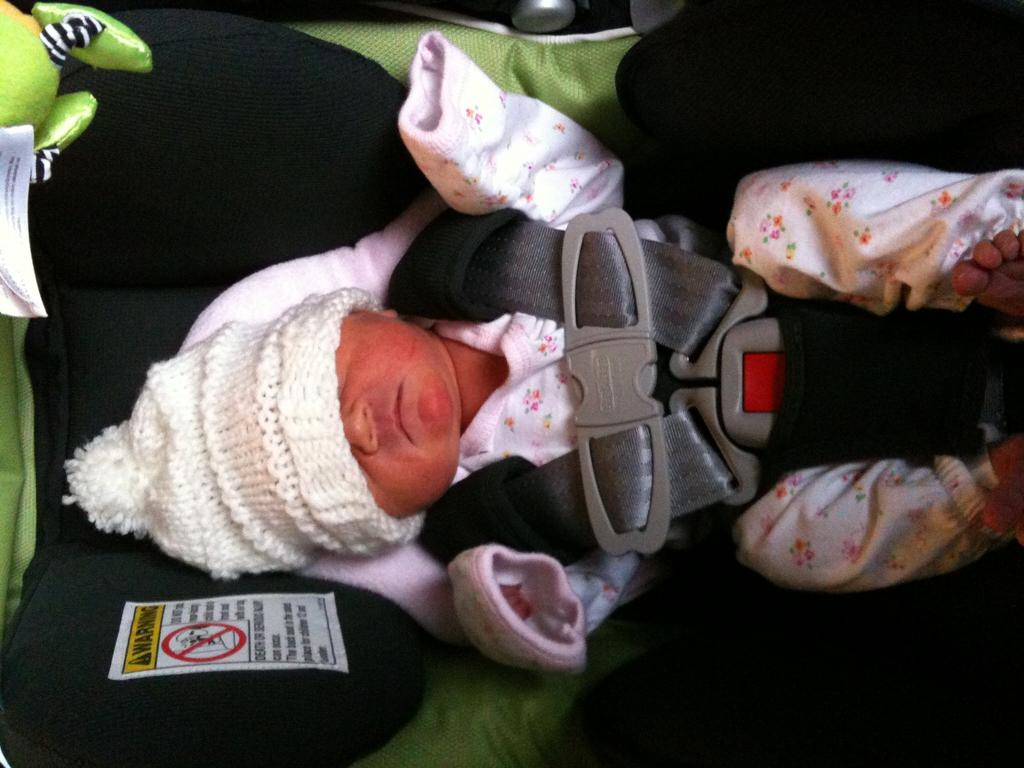What is the main subject of the image? There is a baby in the image. What else can be seen in the image besides the baby? There is a signboard in the image. What type of approval does the baby need from society in the image? There is no indication in the image that the baby needs any approval from society. 